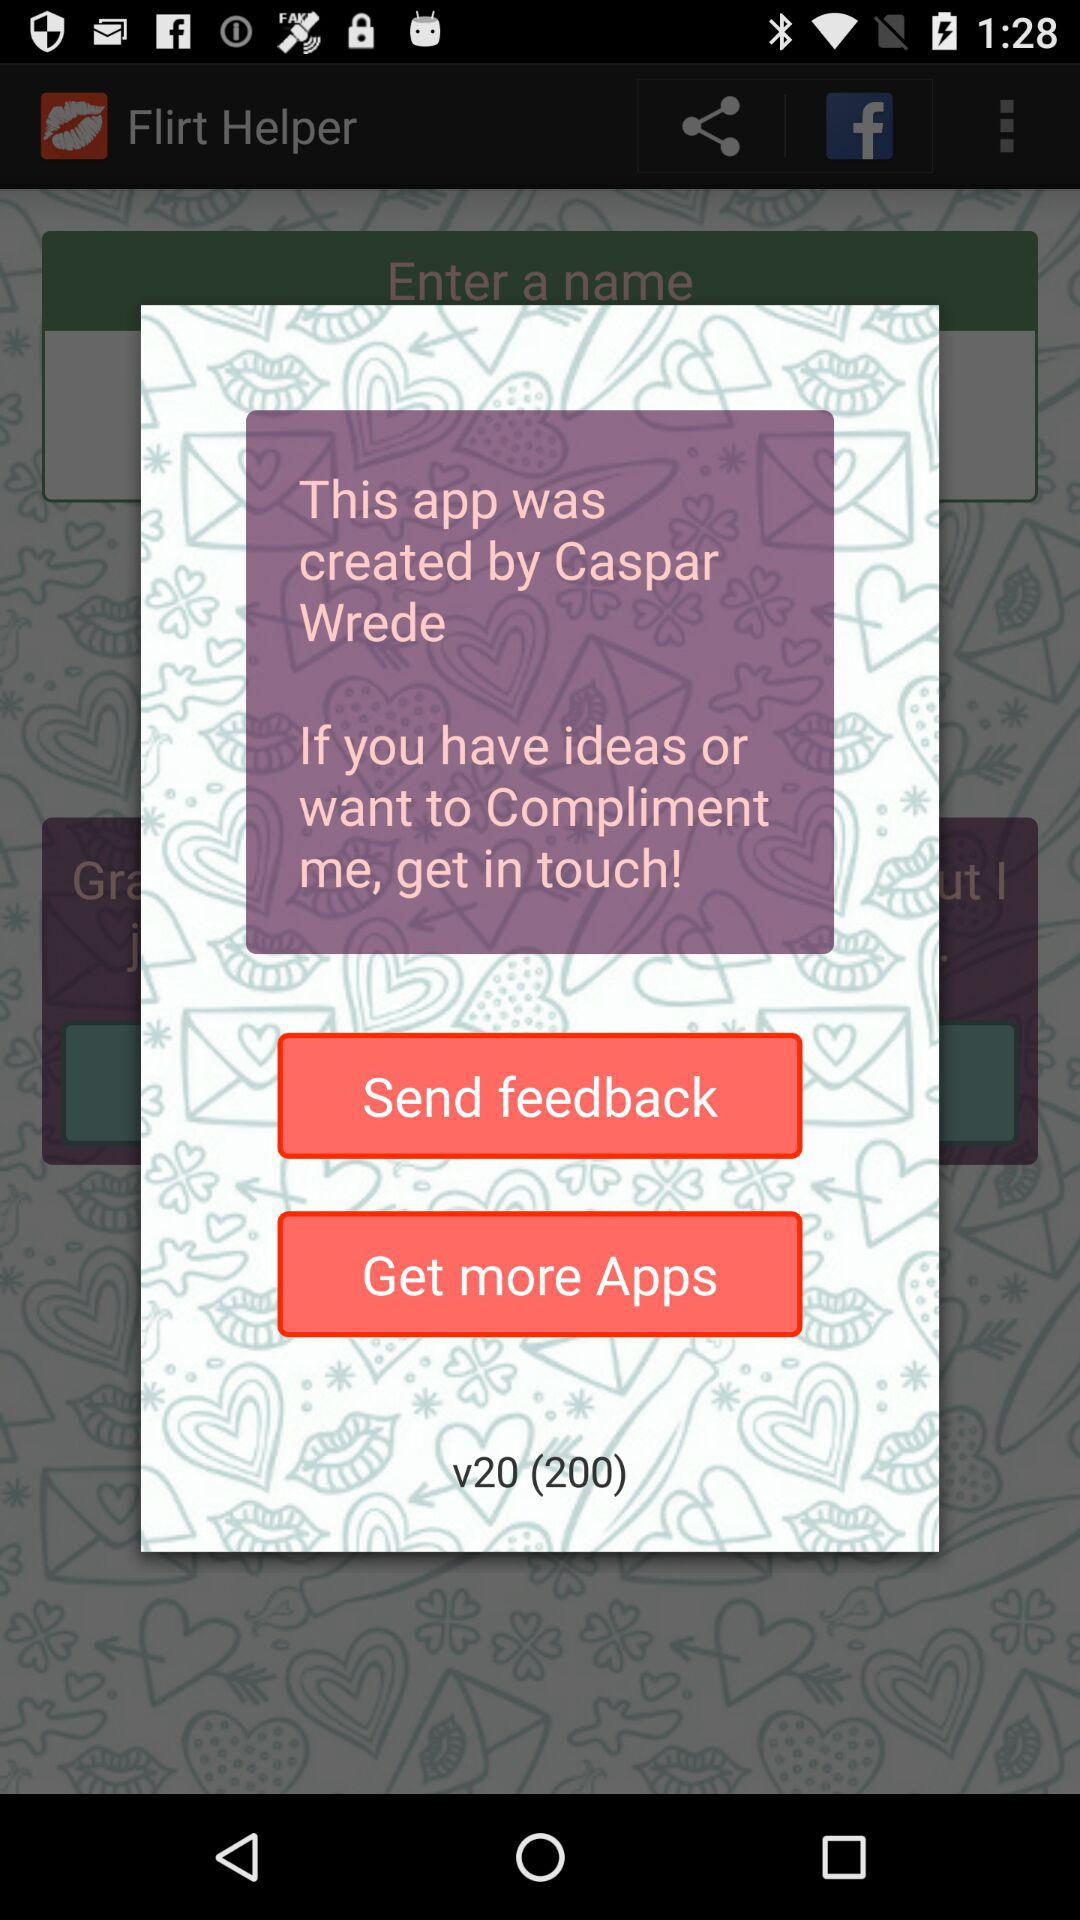What is the version of the application? The version of the application is v20 (200). 